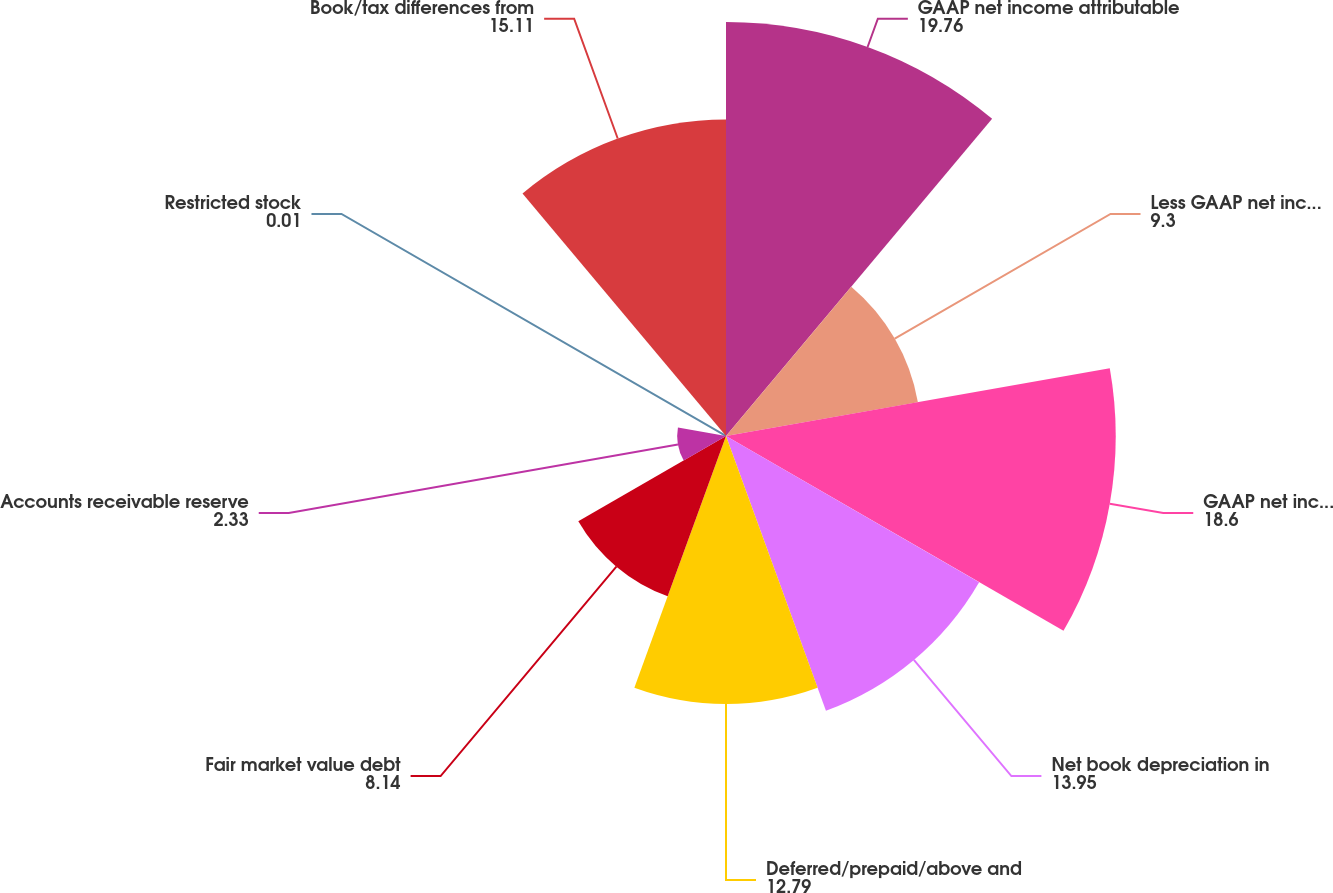Convert chart to OTSL. <chart><loc_0><loc_0><loc_500><loc_500><pie_chart><fcel>GAAP net income attributable<fcel>Less GAAP net income of<fcel>GAAP net income from REIT<fcel>Net book depreciation in<fcel>Deferred/prepaid/above and<fcel>Fair market value debt<fcel>Accounts receivable reserve<fcel>Restricted stock<fcel>Book/tax differences from<nl><fcel>19.76%<fcel>9.3%<fcel>18.6%<fcel>13.95%<fcel>12.79%<fcel>8.14%<fcel>2.33%<fcel>0.01%<fcel>15.11%<nl></chart> 